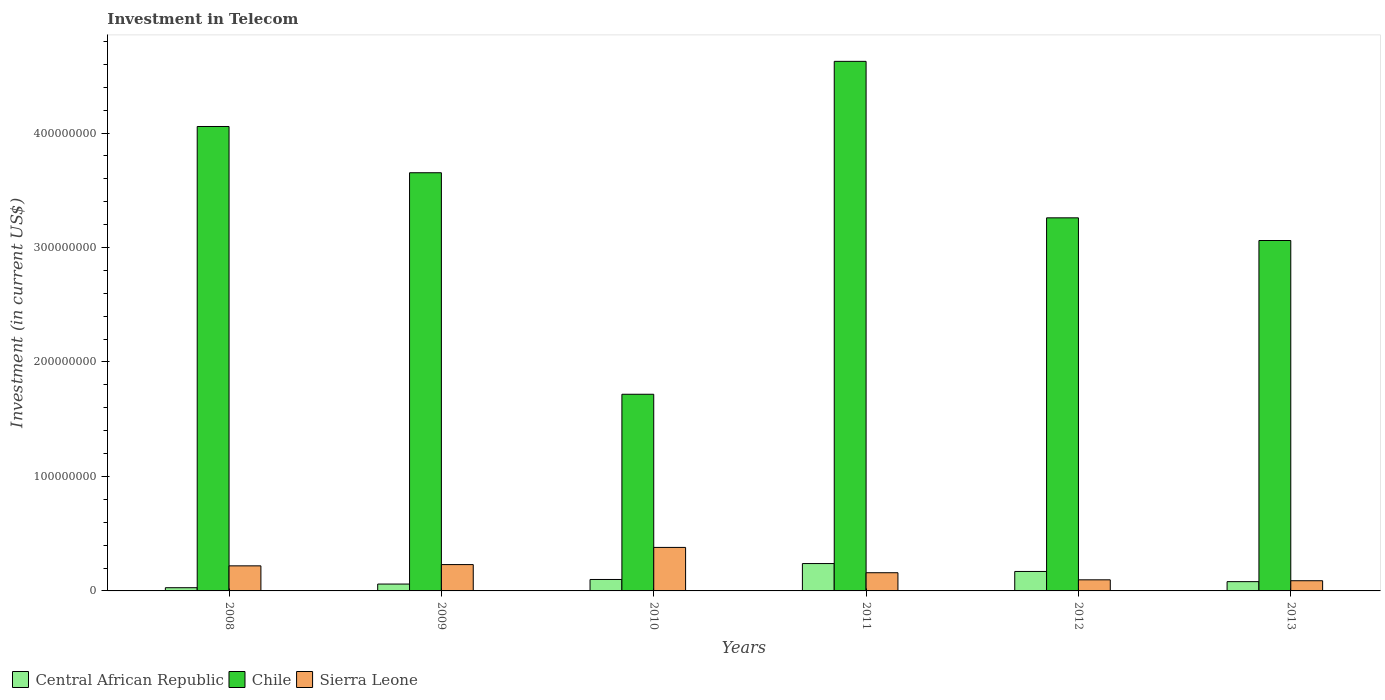How many groups of bars are there?
Provide a succinct answer. 6. Are the number of bars per tick equal to the number of legend labels?
Provide a short and direct response. Yes. How many bars are there on the 1st tick from the left?
Offer a terse response. 3. How many bars are there on the 5th tick from the right?
Your answer should be compact. 3. In how many cases, is the number of bars for a given year not equal to the number of legend labels?
Offer a very short reply. 0. Across all years, what is the maximum amount invested in telecom in Chile?
Provide a succinct answer. 4.63e+08. Across all years, what is the minimum amount invested in telecom in Central African Republic?
Offer a very short reply. 2.80e+06. In which year was the amount invested in telecom in Sierra Leone maximum?
Provide a short and direct response. 2010. What is the total amount invested in telecom in Sierra Leone in the graph?
Your response must be concise. 1.17e+08. What is the difference between the amount invested in telecom in Chile in 2008 and that in 2012?
Offer a very short reply. 7.98e+07. What is the difference between the amount invested in telecom in Chile in 2008 and the amount invested in telecom in Sierra Leone in 2011?
Offer a terse response. 3.90e+08. What is the average amount invested in telecom in Sierra Leone per year?
Make the answer very short. 1.96e+07. In the year 2012, what is the difference between the amount invested in telecom in Chile and amount invested in telecom in Sierra Leone?
Your response must be concise. 3.16e+08. In how many years, is the amount invested in telecom in Sierra Leone greater than 40000000 US$?
Offer a very short reply. 0. What is the ratio of the amount invested in telecom in Sierra Leone in 2009 to that in 2011?
Your response must be concise. 1.45. What is the difference between the highest and the second highest amount invested in telecom in Sierra Leone?
Offer a very short reply. 1.50e+07. What is the difference between the highest and the lowest amount invested in telecom in Sierra Leone?
Your answer should be very brief. 2.91e+07. In how many years, is the amount invested in telecom in Sierra Leone greater than the average amount invested in telecom in Sierra Leone taken over all years?
Offer a very short reply. 3. Is the sum of the amount invested in telecom in Sierra Leone in 2011 and 2012 greater than the maximum amount invested in telecom in Chile across all years?
Make the answer very short. No. What does the 3rd bar from the left in 2011 represents?
Your answer should be compact. Sierra Leone. What does the 3rd bar from the right in 2010 represents?
Keep it short and to the point. Central African Republic. How many years are there in the graph?
Give a very brief answer. 6. Does the graph contain grids?
Your answer should be compact. No. How are the legend labels stacked?
Provide a succinct answer. Horizontal. What is the title of the graph?
Your answer should be very brief. Investment in Telecom. Does "Greenland" appear as one of the legend labels in the graph?
Provide a succinct answer. No. What is the label or title of the Y-axis?
Make the answer very short. Investment (in current US$). What is the Investment (in current US$) in Central African Republic in 2008?
Your answer should be compact. 2.80e+06. What is the Investment (in current US$) in Chile in 2008?
Offer a very short reply. 4.06e+08. What is the Investment (in current US$) in Sierra Leone in 2008?
Offer a terse response. 2.19e+07. What is the Investment (in current US$) in Central African Republic in 2009?
Keep it short and to the point. 6.00e+06. What is the Investment (in current US$) in Chile in 2009?
Give a very brief answer. 3.65e+08. What is the Investment (in current US$) of Sierra Leone in 2009?
Offer a very short reply. 2.30e+07. What is the Investment (in current US$) of Central African Republic in 2010?
Ensure brevity in your answer.  1.00e+07. What is the Investment (in current US$) in Chile in 2010?
Your response must be concise. 1.72e+08. What is the Investment (in current US$) of Sierra Leone in 2010?
Provide a succinct answer. 3.80e+07. What is the Investment (in current US$) in Central African Republic in 2011?
Provide a short and direct response. 2.39e+07. What is the Investment (in current US$) in Chile in 2011?
Your response must be concise. 4.63e+08. What is the Investment (in current US$) in Sierra Leone in 2011?
Give a very brief answer. 1.59e+07. What is the Investment (in current US$) in Central African Republic in 2012?
Make the answer very short. 1.70e+07. What is the Investment (in current US$) in Chile in 2012?
Your answer should be very brief. 3.26e+08. What is the Investment (in current US$) in Sierra Leone in 2012?
Provide a succinct answer. 9.70e+06. What is the Investment (in current US$) in Central African Republic in 2013?
Ensure brevity in your answer.  8.10e+06. What is the Investment (in current US$) in Chile in 2013?
Your response must be concise. 3.06e+08. What is the Investment (in current US$) of Sierra Leone in 2013?
Provide a succinct answer. 8.90e+06. Across all years, what is the maximum Investment (in current US$) in Central African Republic?
Keep it short and to the point. 2.39e+07. Across all years, what is the maximum Investment (in current US$) of Chile?
Provide a succinct answer. 4.63e+08. Across all years, what is the maximum Investment (in current US$) of Sierra Leone?
Keep it short and to the point. 3.80e+07. Across all years, what is the minimum Investment (in current US$) in Central African Republic?
Make the answer very short. 2.80e+06. Across all years, what is the minimum Investment (in current US$) in Chile?
Provide a succinct answer. 1.72e+08. Across all years, what is the minimum Investment (in current US$) in Sierra Leone?
Give a very brief answer. 8.90e+06. What is the total Investment (in current US$) in Central African Republic in the graph?
Ensure brevity in your answer.  6.78e+07. What is the total Investment (in current US$) in Chile in the graph?
Your answer should be compact. 2.04e+09. What is the total Investment (in current US$) in Sierra Leone in the graph?
Offer a terse response. 1.17e+08. What is the difference between the Investment (in current US$) of Central African Republic in 2008 and that in 2009?
Ensure brevity in your answer.  -3.20e+06. What is the difference between the Investment (in current US$) of Chile in 2008 and that in 2009?
Keep it short and to the point. 4.04e+07. What is the difference between the Investment (in current US$) of Sierra Leone in 2008 and that in 2009?
Your response must be concise. -1.10e+06. What is the difference between the Investment (in current US$) of Central African Republic in 2008 and that in 2010?
Provide a short and direct response. -7.20e+06. What is the difference between the Investment (in current US$) of Chile in 2008 and that in 2010?
Your response must be concise. 2.34e+08. What is the difference between the Investment (in current US$) of Sierra Leone in 2008 and that in 2010?
Ensure brevity in your answer.  -1.61e+07. What is the difference between the Investment (in current US$) of Central African Republic in 2008 and that in 2011?
Make the answer very short. -2.11e+07. What is the difference between the Investment (in current US$) in Chile in 2008 and that in 2011?
Your answer should be very brief. -5.69e+07. What is the difference between the Investment (in current US$) in Central African Republic in 2008 and that in 2012?
Your answer should be very brief. -1.42e+07. What is the difference between the Investment (in current US$) in Chile in 2008 and that in 2012?
Offer a very short reply. 7.98e+07. What is the difference between the Investment (in current US$) of Sierra Leone in 2008 and that in 2012?
Provide a succinct answer. 1.22e+07. What is the difference between the Investment (in current US$) in Central African Republic in 2008 and that in 2013?
Provide a succinct answer. -5.30e+06. What is the difference between the Investment (in current US$) in Chile in 2008 and that in 2013?
Make the answer very short. 9.96e+07. What is the difference between the Investment (in current US$) in Sierra Leone in 2008 and that in 2013?
Your answer should be compact. 1.30e+07. What is the difference between the Investment (in current US$) in Chile in 2009 and that in 2010?
Offer a terse response. 1.94e+08. What is the difference between the Investment (in current US$) of Sierra Leone in 2009 and that in 2010?
Offer a terse response. -1.50e+07. What is the difference between the Investment (in current US$) of Central African Republic in 2009 and that in 2011?
Ensure brevity in your answer.  -1.79e+07. What is the difference between the Investment (in current US$) of Chile in 2009 and that in 2011?
Your answer should be very brief. -9.73e+07. What is the difference between the Investment (in current US$) of Sierra Leone in 2009 and that in 2011?
Keep it short and to the point. 7.10e+06. What is the difference between the Investment (in current US$) in Central African Republic in 2009 and that in 2012?
Ensure brevity in your answer.  -1.10e+07. What is the difference between the Investment (in current US$) in Chile in 2009 and that in 2012?
Give a very brief answer. 3.94e+07. What is the difference between the Investment (in current US$) of Sierra Leone in 2009 and that in 2012?
Give a very brief answer. 1.33e+07. What is the difference between the Investment (in current US$) of Central African Republic in 2009 and that in 2013?
Provide a succinct answer. -2.10e+06. What is the difference between the Investment (in current US$) of Chile in 2009 and that in 2013?
Provide a succinct answer. 5.92e+07. What is the difference between the Investment (in current US$) of Sierra Leone in 2009 and that in 2013?
Ensure brevity in your answer.  1.41e+07. What is the difference between the Investment (in current US$) of Central African Republic in 2010 and that in 2011?
Provide a succinct answer. -1.39e+07. What is the difference between the Investment (in current US$) in Chile in 2010 and that in 2011?
Keep it short and to the point. -2.91e+08. What is the difference between the Investment (in current US$) of Sierra Leone in 2010 and that in 2011?
Your response must be concise. 2.21e+07. What is the difference between the Investment (in current US$) of Central African Republic in 2010 and that in 2012?
Ensure brevity in your answer.  -7.00e+06. What is the difference between the Investment (in current US$) in Chile in 2010 and that in 2012?
Provide a succinct answer. -1.54e+08. What is the difference between the Investment (in current US$) in Sierra Leone in 2010 and that in 2012?
Give a very brief answer. 2.83e+07. What is the difference between the Investment (in current US$) of Central African Republic in 2010 and that in 2013?
Ensure brevity in your answer.  1.90e+06. What is the difference between the Investment (in current US$) in Chile in 2010 and that in 2013?
Your answer should be very brief. -1.34e+08. What is the difference between the Investment (in current US$) in Sierra Leone in 2010 and that in 2013?
Give a very brief answer. 2.91e+07. What is the difference between the Investment (in current US$) in Central African Republic in 2011 and that in 2012?
Make the answer very short. 6.90e+06. What is the difference between the Investment (in current US$) of Chile in 2011 and that in 2012?
Offer a very short reply. 1.37e+08. What is the difference between the Investment (in current US$) in Sierra Leone in 2011 and that in 2012?
Give a very brief answer. 6.20e+06. What is the difference between the Investment (in current US$) of Central African Republic in 2011 and that in 2013?
Your answer should be compact. 1.58e+07. What is the difference between the Investment (in current US$) of Chile in 2011 and that in 2013?
Your answer should be compact. 1.56e+08. What is the difference between the Investment (in current US$) of Sierra Leone in 2011 and that in 2013?
Keep it short and to the point. 7.00e+06. What is the difference between the Investment (in current US$) in Central African Republic in 2012 and that in 2013?
Provide a succinct answer. 8.90e+06. What is the difference between the Investment (in current US$) of Chile in 2012 and that in 2013?
Provide a short and direct response. 1.98e+07. What is the difference between the Investment (in current US$) in Central African Republic in 2008 and the Investment (in current US$) in Chile in 2009?
Your answer should be compact. -3.62e+08. What is the difference between the Investment (in current US$) in Central African Republic in 2008 and the Investment (in current US$) in Sierra Leone in 2009?
Give a very brief answer. -2.02e+07. What is the difference between the Investment (in current US$) of Chile in 2008 and the Investment (in current US$) of Sierra Leone in 2009?
Offer a very short reply. 3.83e+08. What is the difference between the Investment (in current US$) in Central African Republic in 2008 and the Investment (in current US$) in Chile in 2010?
Offer a terse response. -1.69e+08. What is the difference between the Investment (in current US$) in Central African Republic in 2008 and the Investment (in current US$) in Sierra Leone in 2010?
Your answer should be compact. -3.52e+07. What is the difference between the Investment (in current US$) of Chile in 2008 and the Investment (in current US$) of Sierra Leone in 2010?
Make the answer very short. 3.68e+08. What is the difference between the Investment (in current US$) of Central African Republic in 2008 and the Investment (in current US$) of Chile in 2011?
Offer a very short reply. -4.60e+08. What is the difference between the Investment (in current US$) of Central African Republic in 2008 and the Investment (in current US$) of Sierra Leone in 2011?
Your answer should be very brief. -1.31e+07. What is the difference between the Investment (in current US$) of Chile in 2008 and the Investment (in current US$) of Sierra Leone in 2011?
Offer a terse response. 3.90e+08. What is the difference between the Investment (in current US$) of Central African Republic in 2008 and the Investment (in current US$) of Chile in 2012?
Your response must be concise. -3.23e+08. What is the difference between the Investment (in current US$) in Central African Republic in 2008 and the Investment (in current US$) in Sierra Leone in 2012?
Ensure brevity in your answer.  -6.90e+06. What is the difference between the Investment (in current US$) of Chile in 2008 and the Investment (in current US$) of Sierra Leone in 2012?
Provide a succinct answer. 3.96e+08. What is the difference between the Investment (in current US$) of Central African Republic in 2008 and the Investment (in current US$) of Chile in 2013?
Offer a very short reply. -3.03e+08. What is the difference between the Investment (in current US$) in Central African Republic in 2008 and the Investment (in current US$) in Sierra Leone in 2013?
Your answer should be very brief. -6.10e+06. What is the difference between the Investment (in current US$) in Chile in 2008 and the Investment (in current US$) in Sierra Leone in 2013?
Keep it short and to the point. 3.97e+08. What is the difference between the Investment (in current US$) in Central African Republic in 2009 and the Investment (in current US$) in Chile in 2010?
Offer a very short reply. -1.66e+08. What is the difference between the Investment (in current US$) of Central African Republic in 2009 and the Investment (in current US$) of Sierra Leone in 2010?
Keep it short and to the point. -3.20e+07. What is the difference between the Investment (in current US$) of Chile in 2009 and the Investment (in current US$) of Sierra Leone in 2010?
Your answer should be very brief. 3.27e+08. What is the difference between the Investment (in current US$) in Central African Republic in 2009 and the Investment (in current US$) in Chile in 2011?
Give a very brief answer. -4.57e+08. What is the difference between the Investment (in current US$) of Central African Republic in 2009 and the Investment (in current US$) of Sierra Leone in 2011?
Offer a terse response. -9.90e+06. What is the difference between the Investment (in current US$) in Chile in 2009 and the Investment (in current US$) in Sierra Leone in 2011?
Ensure brevity in your answer.  3.49e+08. What is the difference between the Investment (in current US$) in Central African Republic in 2009 and the Investment (in current US$) in Chile in 2012?
Make the answer very short. -3.20e+08. What is the difference between the Investment (in current US$) in Central African Republic in 2009 and the Investment (in current US$) in Sierra Leone in 2012?
Provide a short and direct response. -3.70e+06. What is the difference between the Investment (in current US$) in Chile in 2009 and the Investment (in current US$) in Sierra Leone in 2012?
Provide a short and direct response. 3.56e+08. What is the difference between the Investment (in current US$) in Central African Republic in 2009 and the Investment (in current US$) in Chile in 2013?
Provide a succinct answer. -3.00e+08. What is the difference between the Investment (in current US$) of Central African Republic in 2009 and the Investment (in current US$) of Sierra Leone in 2013?
Give a very brief answer. -2.90e+06. What is the difference between the Investment (in current US$) of Chile in 2009 and the Investment (in current US$) of Sierra Leone in 2013?
Provide a short and direct response. 3.56e+08. What is the difference between the Investment (in current US$) of Central African Republic in 2010 and the Investment (in current US$) of Chile in 2011?
Your answer should be compact. -4.53e+08. What is the difference between the Investment (in current US$) of Central African Republic in 2010 and the Investment (in current US$) of Sierra Leone in 2011?
Ensure brevity in your answer.  -5.90e+06. What is the difference between the Investment (in current US$) in Chile in 2010 and the Investment (in current US$) in Sierra Leone in 2011?
Make the answer very short. 1.56e+08. What is the difference between the Investment (in current US$) in Central African Republic in 2010 and the Investment (in current US$) in Chile in 2012?
Your answer should be compact. -3.16e+08. What is the difference between the Investment (in current US$) of Central African Republic in 2010 and the Investment (in current US$) of Sierra Leone in 2012?
Keep it short and to the point. 3.00e+05. What is the difference between the Investment (in current US$) of Chile in 2010 and the Investment (in current US$) of Sierra Leone in 2012?
Provide a short and direct response. 1.62e+08. What is the difference between the Investment (in current US$) in Central African Republic in 2010 and the Investment (in current US$) in Chile in 2013?
Offer a very short reply. -2.96e+08. What is the difference between the Investment (in current US$) of Central African Republic in 2010 and the Investment (in current US$) of Sierra Leone in 2013?
Your answer should be very brief. 1.10e+06. What is the difference between the Investment (in current US$) of Chile in 2010 and the Investment (in current US$) of Sierra Leone in 2013?
Offer a terse response. 1.63e+08. What is the difference between the Investment (in current US$) in Central African Republic in 2011 and the Investment (in current US$) in Chile in 2012?
Give a very brief answer. -3.02e+08. What is the difference between the Investment (in current US$) in Central African Republic in 2011 and the Investment (in current US$) in Sierra Leone in 2012?
Offer a very short reply. 1.42e+07. What is the difference between the Investment (in current US$) in Chile in 2011 and the Investment (in current US$) in Sierra Leone in 2012?
Provide a short and direct response. 4.53e+08. What is the difference between the Investment (in current US$) of Central African Republic in 2011 and the Investment (in current US$) of Chile in 2013?
Provide a succinct answer. -2.82e+08. What is the difference between the Investment (in current US$) in Central African Republic in 2011 and the Investment (in current US$) in Sierra Leone in 2013?
Your response must be concise. 1.50e+07. What is the difference between the Investment (in current US$) in Chile in 2011 and the Investment (in current US$) in Sierra Leone in 2013?
Provide a succinct answer. 4.54e+08. What is the difference between the Investment (in current US$) of Central African Republic in 2012 and the Investment (in current US$) of Chile in 2013?
Your answer should be compact. -2.89e+08. What is the difference between the Investment (in current US$) of Central African Republic in 2012 and the Investment (in current US$) of Sierra Leone in 2013?
Your answer should be compact. 8.10e+06. What is the difference between the Investment (in current US$) in Chile in 2012 and the Investment (in current US$) in Sierra Leone in 2013?
Keep it short and to the point. 3.17e+08. What is the average Investment (in current US$) in Central African Republic per year?
Offer a terse response. 1.13e+07. What is the average Investment (in current US$) of Chile per year?
Offer a terse response. 3.40e+08. What is the average Investment (in current US$) in Sierra Leone per year?
Offer a terse response. 1.96e+07. In the year 2008, what is the difference between the Investment (in current US$) in Central African Republic and Investment (in current US$) in Chile?
Offer a terse response. -4.03e+08. In the year 2008, what is the difference between the Investment (in current US$) in Central African Republic and Investment (in current US$) in Sierra Leone?
Your answer should be compact. -1.91e+07. In the year 2008, what is the difference between the Investment (in current US$) of Chile and Investment (in current US$) of Sierra Leone?
Make the answer very short. 3.84e+08. In the year 2009, what is the difference between the Investment (in current US$) of Central African Republic and Investment (in current US$) of Chile?
Offer a terse response. -3.59e+08. In the year 2009, what is the difference between the Investment (in current US$) in Central African Republic and Investment (in current US$) in Sierra Leone?
Offer a terse response. -1.70e+07. In the year 2009, what is the difference between the Investment (in current US$) of Chile and Investment (in current US$) of Sierra Leone?
Your answer should be compact. 3.42e+08. In the year 2010, what is the difference between the Investment (in current US$) of Central African Republic and Investment (in current US$) of Chile?
Your answer should be compact. -1.62e+08. In the year 2010, what is the difference between the Investment (in current US$) of Central African Republic and Investment (in current US$) of Sierra Leone?
Your answer should be very brief. -2.80e+07. In the year 2010, what is the difference between the Investment (in current US$) in Chile and Investment (in current US$) in Sierra Leone?
Make the answer very short. 1.34e+08. In the year 2011, what is the difference between the Investment (in current US$) of Central African Republic and Investment (in current US$) of Chile?
Offer a very short reply. -4.39e+08. In the year 2011, what is the difference between the Investment (in current US$) of Central African Republic and Investment (in current US$) of Sierra Leone?
Your answer should be very brief. 8.00e+06. In the year 2011, what is the difference between the Investment (in current US$) of Chile and Investment (in current US$) of Sierra Leone?
Your answer should be compact. 4.47e+08. In the year 2012, what is the difference between the Investment (in current US$) in Central African Republic and Investment (in current US$) in Chile?
Provide a short and direct response. -3.09e+08. In the year 2012, what is the difference between the Investment (in current US$) in Central African Republic and Investment (in current US$) in Sierra Leone?
Ensure brevity in your answer.  7.30e+06. In the year 2012, what is the difference between the Investment (in current US$) in Chile and Investment (in current US$) in Sierra Leone?
Give a very brief answer. 3.16e+08. In the year 2013, what is the difference between the Investment (in current US$) in Central African Republic and Investment (in current US$) in Chile?
Ensure brevity in your answer.  -2.98e+08. In the year 2013, what is the difference between the Investment (in current US$) of Central African Republic and Investment (in current US$) of Sierra Leone?
Give a very brief answer. -8.00e+05. In the year 2013, what is the difference between the Investment (in current US$) in Chile and Investment (in current US$) in Sierra Leone?
Your answer should be compact. 2.97e+08. What is the ratio of the Investment (in current US$) of Central African Republic in 2008 to that in 2009?
Provide a succinct answer. 0.47. What is the ratio of the Investment (in current US$) in Chile in 2008 to that in 2009?
Provide a short and direct response. 1.11. What is the ratio of the Investment (in current US$) of Sierra Leone in 2008 to that in 2009?
Make the answer very short. 0.95. What is the ratio of the Investment (in current US$) in Central African Republic in 2008 to that in 2010?
Ensure brevity in your answer.  0.28. What is the ratio of the Investment (in current US$) of Chile in 2008 to that in 2010?
Make the answer very short. 2.36. What is the ratio of the Investment (in current US$) in Sierra Leone in 2008 to that in 2010?
Your answer should be compact. 0.58. What is the ratio of the Investment (in current US$) in Central African Republic in 2008 to that in 2011?
Provide a short and direct response. 0.12. What is the ratio of the Investment (in current US$) of Chile in 2008 to that in 2011?
Offer a terse response. 0.88. What is the ratio of the Investment (in current US$) in Sierra Leone in 2008 to that in 2011?
Your answer should be very brief. 1.38. What is the ratio of the Investment (in current US$) in Central African Republic in 2008 to that in 2012?
Give a very brief answer. 0.16. What is the ratio of the Investment (in current US$) of Chile in 2008 to that in 2012?
Offer a very short reply. 1.24. What is the ratio of the Investment (in current US$) in Sierra Leone in 2008 to that in 2012?
Provide a succinct answer. 2.26. What is the ratio of the Investment (in current US$) of Central African Republic in 2008 to that in 2013?
Ensure brevity in your answer.  0.35. What is the ratio of the Investment (in current US$) in Chile in 2008 to that in 2013?
Keep it short and to the point. 1.33. What is the ratio of the Investment (in current US$) of Sierra Leone in 2008 to that in 2013?
Your answer should be compact. 2.46. What is the ratio of the Investment (in current US$) of Central African Republic in 2009 to that in 2010?
Offer a very short reply. 0.6. What is the ratio of the Investment (in current US$) of Chile in 2009 to that in 2010?
Provide a short and direct response. 2.13. What is the ratio of the Investment (in current US$) of Sierra Leone in 2009 to that in 2010?
Keep it short and to the point. 0.61. What is the ratio of the Investment (in current US$) of Central African Republic in 2009 to that in 2011?
Provide a succinct answer. 0.25. What is the ratio of the Investment (in current US$) of Chile in 2009 to that in 2011?
Your response must be concise. 0.79. What is the ratio of the Investment (in current US$) in Sierra Leone in 2009 to that in 2011?
Your answer should be compact. 1.45. What is the ratio of the Investment (in current US$) in Central African Republic in 2009 to that in 2012?
Make the answer very short. 0.35. What is the ratio of the Investment (in current US$) in Chile in 2009 to that in 2012?
Your answer should be compact. 1.12. What is the ratio of the Investment (in current US$) of Sierra Leone in 2009 to that in 2012?
Your answer should be very brief. 2.37. What is the ratio of the Investment (in current US$) in Central African Republic in 2009 to that in 2013?
Ensure brevity in your answer.  0.74. What is the ratio of the Investment (in current US$) of Chile in 2009 to that in 2013?
Offer a terse response. 1.19. What is the ratio of the Investment (in current US$) of Sierra Leone in 2009 to that in 2013?
Provide a short and direct response. 2.58. What is the ratio of the Investment (in current US$) of Central African Republic in 2010 to that in 2011?
Your response must be concise. 0.42. What is the ratio of the Investment (in current US$) in Chile in 2010 to that in 2011?
Make the answer very short. 0.37. What is the ratio of the Investment (in current US$) in Sierra Leone in 2010 to that in 2011?
Offer a terse response. 2.39. What is the ratio of the Investment (in current US$) in Central African Republic in 2010 to that in 2012?
Give a very brief answer. 0.59. What is the ratio of the Investment (in current US$) in Chile in 2010 to that in 2012?
Your answer should be compact. 0.53. What is the ratio of the Investment (in current US$) in Sierra Leone in 2010 to that in 2012?
Keep it short and to the point. 3.92. What is the ratio of the Investment (in current US$) in Central African Republic in 2010 to that in 2013?
Offer a terse response. 1.23. What is the ratio of the Investment (in current US$) of Chile in 2010 to that in 2013?
Provide a succinct answer. 0.56. What is the ratio of the Investment (in current US$) of Sierra Leone in 2010 to that in 2013?
Your response must be concise. 4.27. What is the ratio of the Investment (in current US$) in Central African Republic in 2011 to that in 2012?
Keep it short and to the point. 1.41. What is the ratio of the Investment (in current US$) of Chile in 2011 to that in 2012?
Offer a terse response. 1.42. What is the ratio of the Investment (in current US$) of Sierra Leone in 2011 to that in 2012?
Provide a succinct answer. 1.64. What is the ratio of the Investment (in current US$) in Central African Republic in 2011 to that in 2013?
Make the answer very short. 2.95. What is the ratio of the Investment (in current US$) of Chile in 2011 to that in 2013?
Give a very brief answer. 1.51. What is the ratio of the Investment (in current US$) in Sierra Leone in 2011 to that in 2013?
Keep it short and to the point. 1.79. What is the ratio of the Investment (in current US$) in Central African Republic in 2012 to that in 2013?
Keep it short and to the point. 2.1. What is the ratio of the Investment (in current US$) of Chile in 2012 to that in 2013?
Your answer should be very brief. 1.06. What is the ratio of the Investment (in current US$) of Sierra Leone in 2012 to that in 2013?
Offer a very short reply. 1.09. What is the difference between the highest and the second highest Investment (in current US$) of Central African Republic?
Your answer should be compact. 6.90e+06. What is the difference between the highest and the second highest Investment (in current US$) in Chile?
Provide a short and direct response. 5.69e+07. What is the difference between the highest and the second highest Investment (in current US$) of Sierra Leone?
Your answer should be compact. 1.50e+07. What is the difference between the highest and the lowest Investment (in current US$) of Central African Republic?
Offer a very short reply. 2.11e+07. What is the difference between the highest and the lowest Investment (in current US$) of Chile?
Offer a very short reply. 2.91e+08. What is the difference between the highest and the lowest Investment (in current US$) of Sierra Leone?
Offer a very short reply. 2.91e+07. 